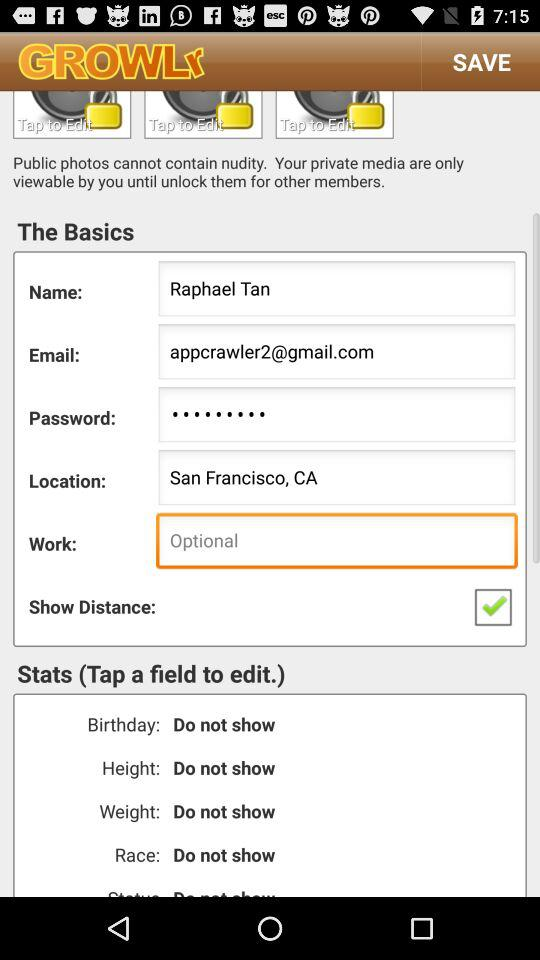What is the location of the user? The location of the user is San Francisco, CA. 